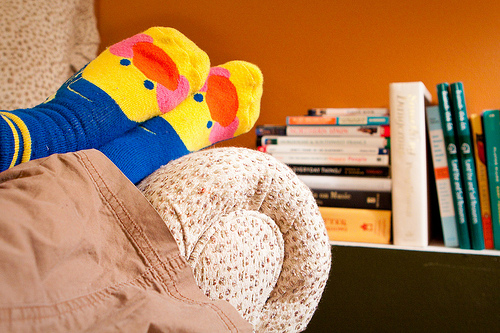<image>
Is there a duck on the couch? Yes. Looking at the image, I can see the duck is positioned on top of the couch, with the couch providing support. 